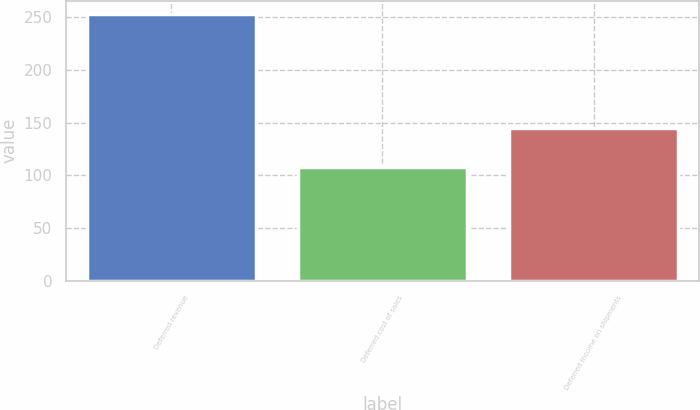Convert chart to OTSL. <chart><loc_0><loc_0><loc_500><loc_500><bar_chart><fcel>Deferred revenue<fcel>Deferred cost of sales<fcel>Deferred income on shipments<nl><fcel>253<fcel>108<fcel>145<nl></chart> 